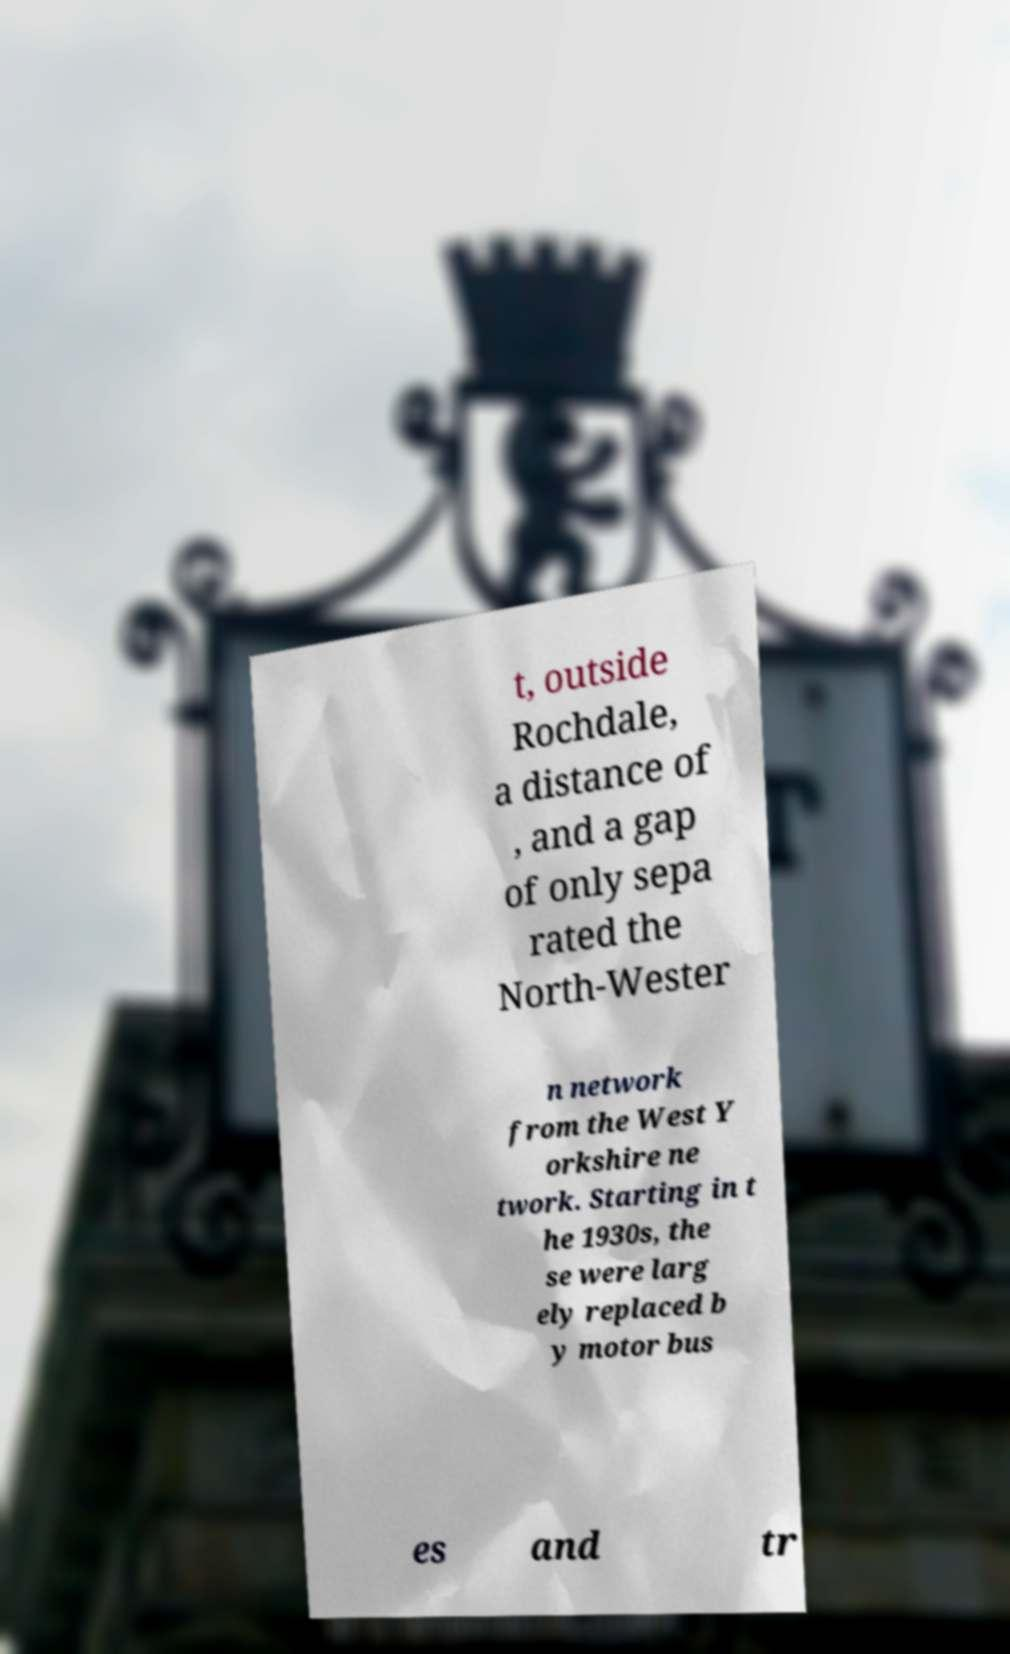Please identify and transcribe the text found in this image. t, outside Rochdale, a distance of , and a gap of only sepa rated the North-Wester n network from the West Y orkshire ne twork. Starting in t he 1930s, the se were larg ely replaced b y motor bus es and tr 